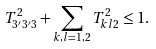<formula> <loc_0><loc_0><loc_500><loc_500>T _ { 3 ^ { \prime } 3 ^ { \prime } 3 } ^ { 2 } + \sum _ { k , l = 1 , 2 } T _ { k l 2 } ^ { 2 } \leq 1 .</formula> 